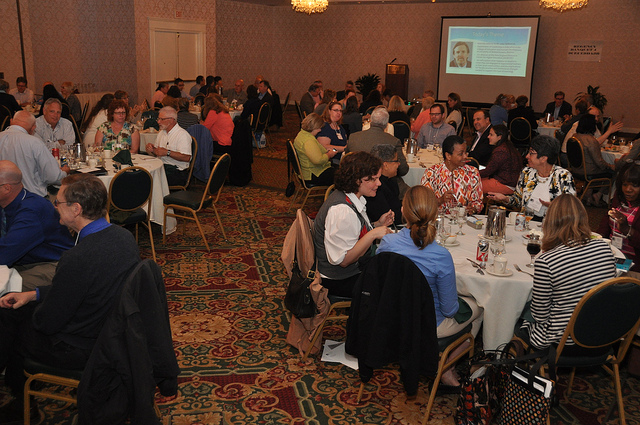How many dining tables are visible? 2 